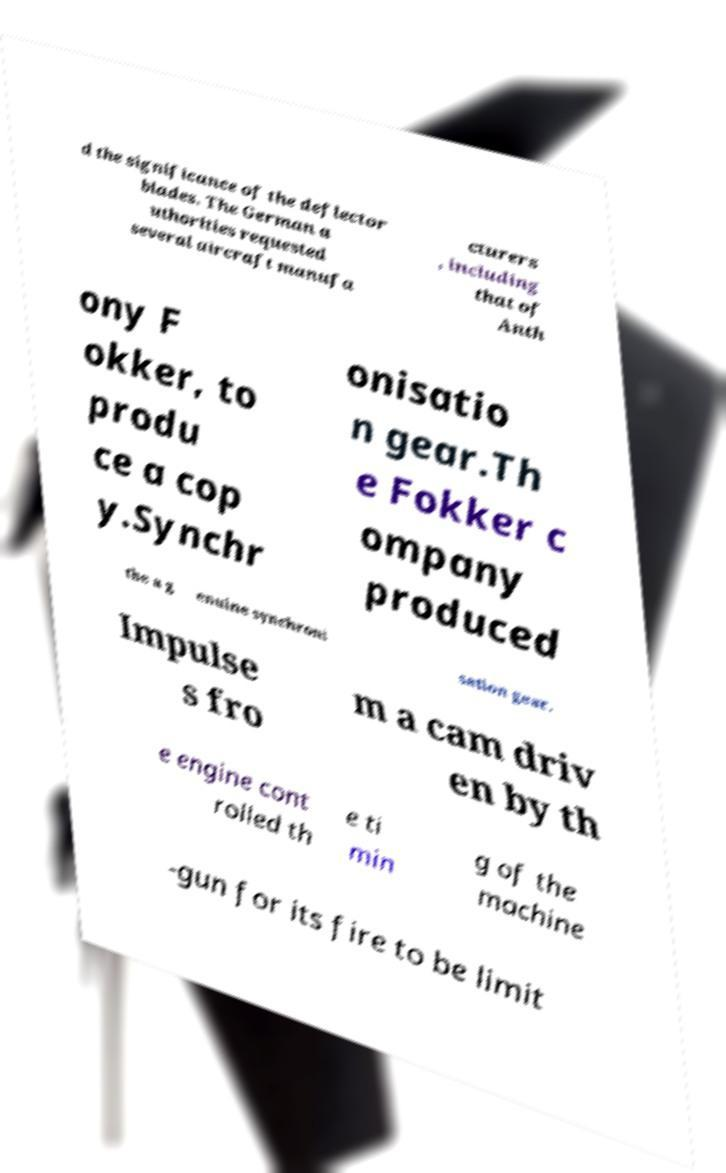Could you extract and type out the text from this image? d the significance of the deflector blades. The German a uthorities requested several aircraft manufa cturers , including that of Anth ony F okker, to produ ce a cop y.Synchr onisatio n gear.Th e Fokker c ompany produced the a g enuine synchroni sation gear. Impulse s fro m a cam driv en by th e engine cont rolled th e ti min g of the machine -gun for its fire to be limit 